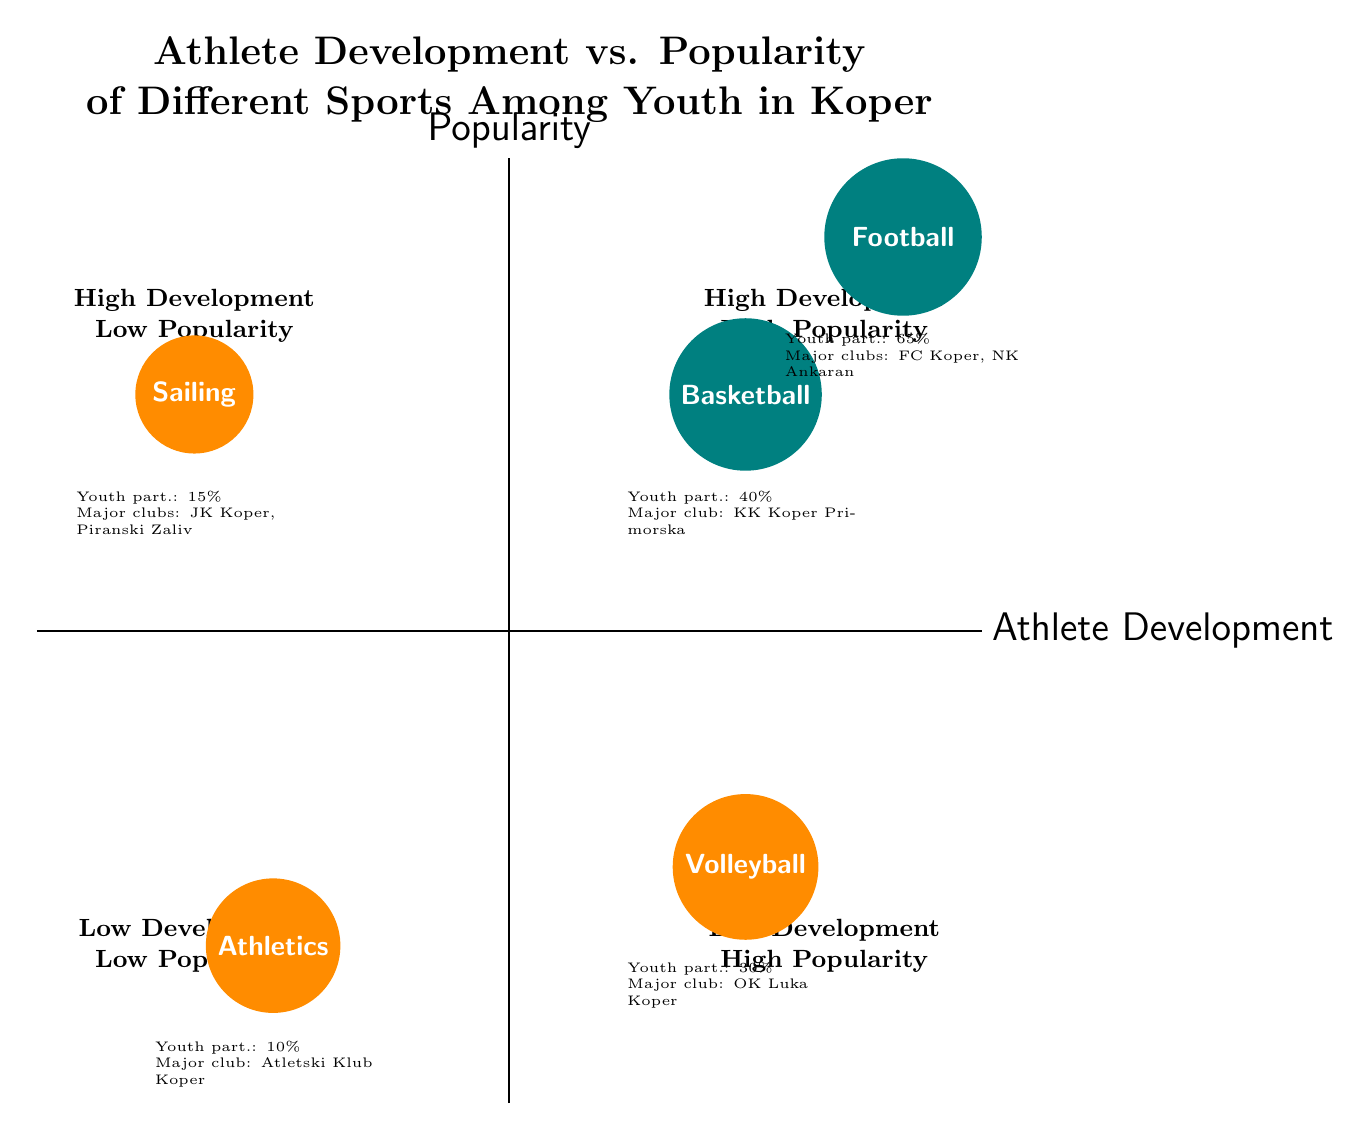What sport has the highest youth participation rate in Koper? By examining the 'high athlete development high popularity' quadrant, we can see that Football has a youth participation rate of 65%, which is the highest among the sports listed in the diagram.
Answer: Football Which sport in Koper has the lowest youth participation rate? Looking at the 'low athlete development low popularity' quadrant, Athletics has a youth participation rate of 10%, the lowest among all the sports shown in the diagram.
Answer: Athletics What are the major clubs for Volleyball? In the 'low athlete development high popularity' quadrant, it is mentioned that the major club for Volleyball in Koper is OK Luka Koper.
Answer: OK Luka Koper How many sports in Koper have high athlete development but low popularity? The 'high athlete development low popularity' quadrant has only one sport listed, which is Sailing. Therefore, there is only one sport in that category.
Answer: 1 Which sport has local success stories of Toni Datković and Vasilij Stanković? These athletes are associated with Football, which is located in the 'high athlete development high popularity' quadrant.
Answer: Football What is the youth participation rate for Sailing? The 'high athlete development low popularity' quadrant indicates that Sailing has a youth participation rate of 15%.
Answer: 15% Which quadrant contains Volleyball? Volleyball is positioned in the 'low athlete development high popularity' quadrant of the diagram.
Answer: Low Development High Popularity Which sport with high athlete development is more popular than Sailing? The comparison shows that both Football and Basketball have higher popularity than Sailing, but we are specifically concerned about high athlete development, thus Basketball, with a youth participation rate of 40%, is indeed more popular.
Answer: Basketball What is the major club for Basketball? In the 'high athlete development high popularity' quadrant, it is indicated that the major club for Basketball is Košarkarski Klub Koper Primorska.
Answer: KK Koper Primorska 